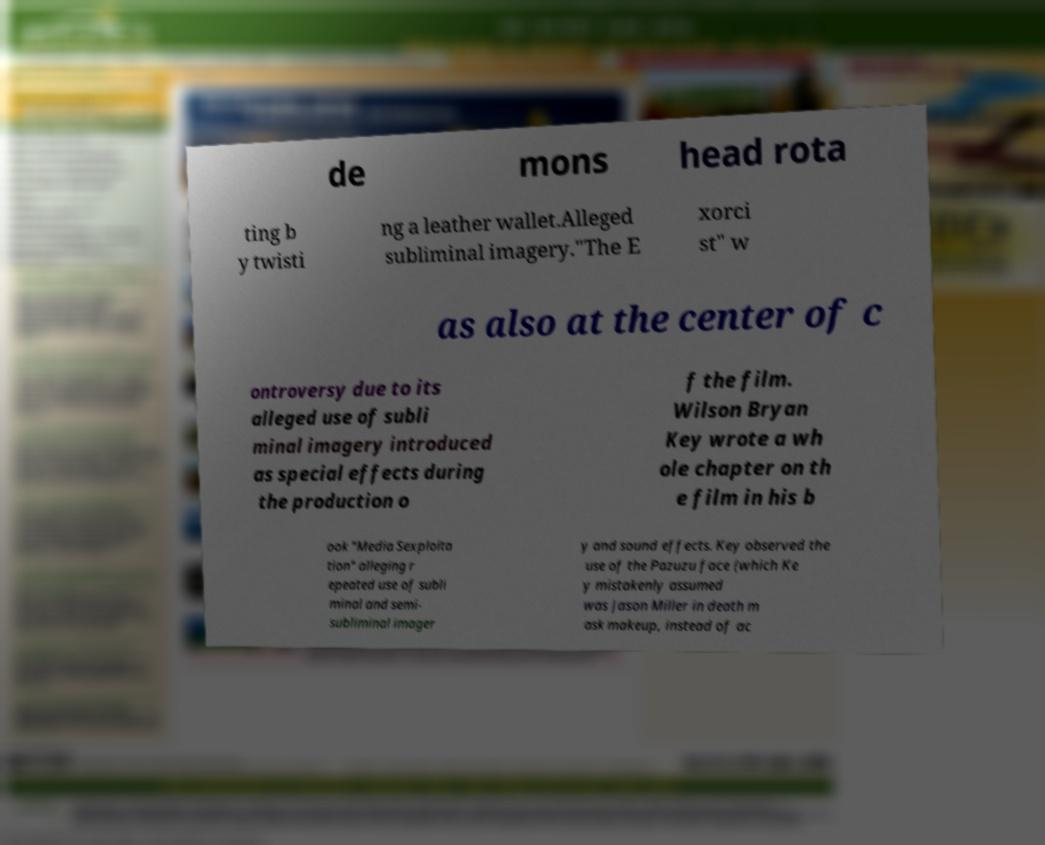Can you read and provide the text displayed in the image?This photo seems to have some interesting text. Can you extract and type it out for me? de mons head rota ting b y twisti ng a leather wallet.Alleged subliminal imagery."The E xorci st" w as also at the center of c ontroversy due to its alleged use of subli minal imagery introduced as special effects during the production o f the film. Wilson Bryan Key wrote a wh ole chapter on th e film in his b ook "Media Sexploita tion" alleging r epeated use of subli minal and semi- subliminal imager y and sound effects. Key observed the use of the Pazuzu face (which Ke y mistakenly assumed was Jason Miller in death m ask makeup, instead of ac 